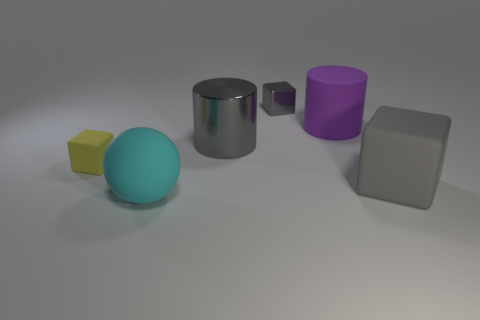How is the lighting in this scene affecting the appearance of the objects? The lighting in the scene creates a soft shadow to the right of the objects, hinting at a light source to the left. It gives the objects a three-dimensional appearance and accentuates their shapes and colors. 